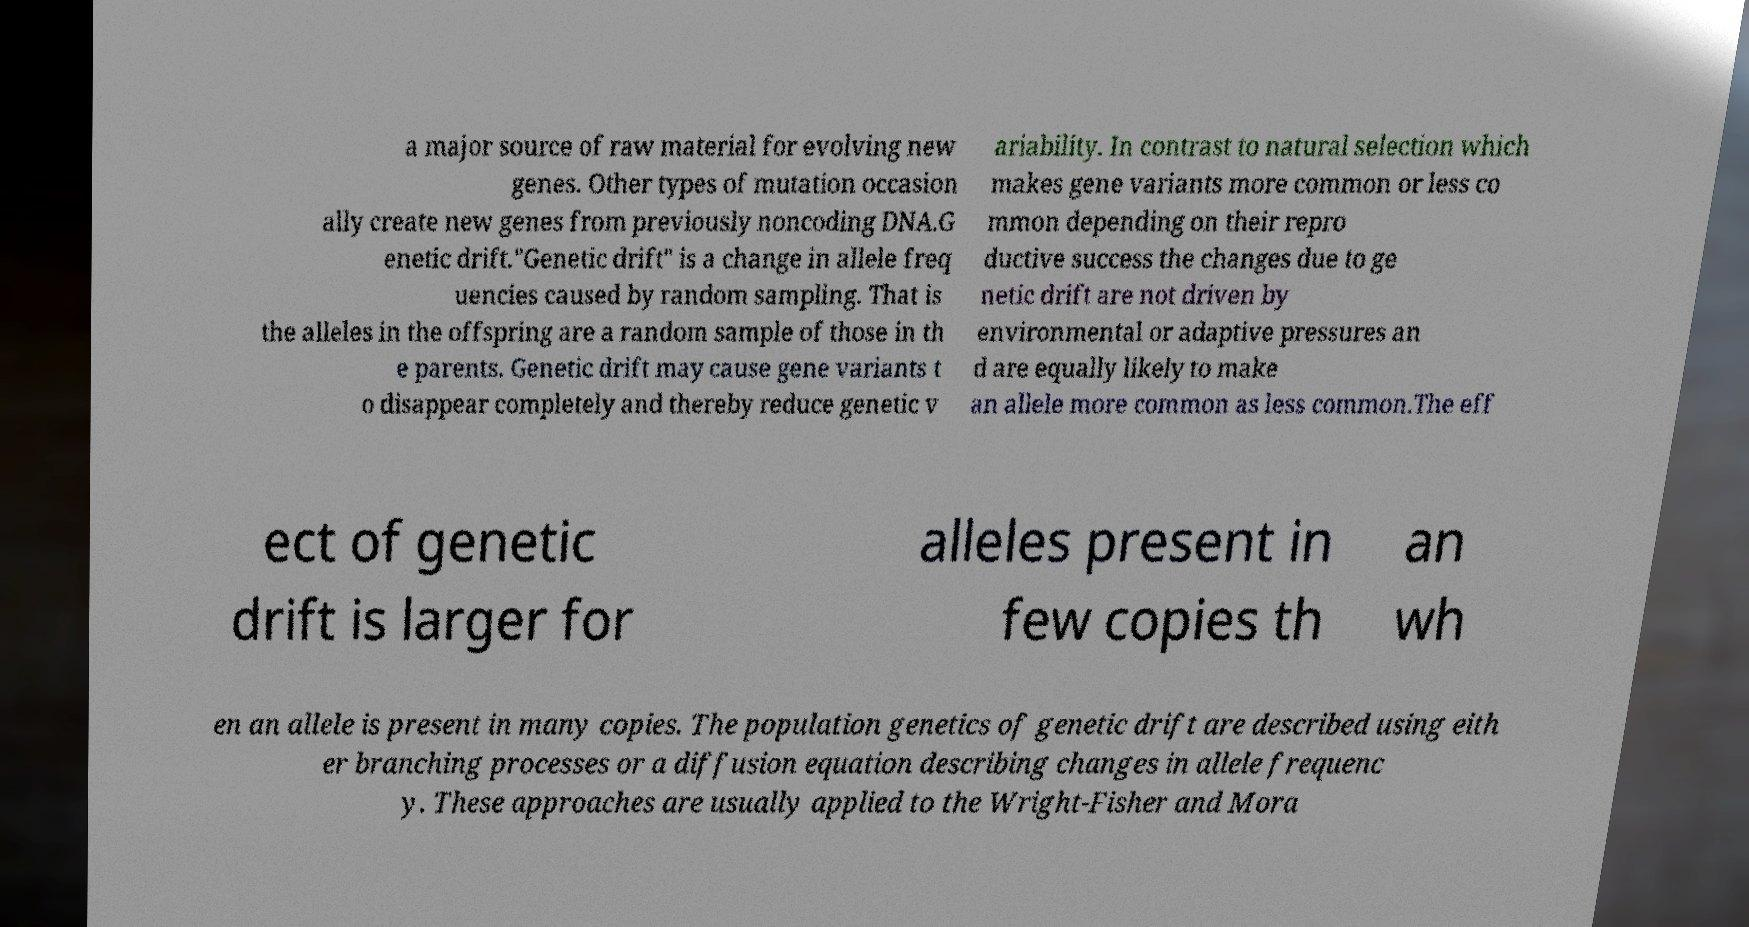Could you assist in decoding the text presented in this image and type it out clearly? a major source of raw material for evolving new genes. Other types of mutation occasion ally create new genes from previously noncoding DNA.G enetic drift."Genetic drift" is a change in allele freq uencies caused by random sampling. That is the alleles in the offspring are a random sample of those in th e parents. Genetic drift may cause gene variants t o disappear completely and thereby reduce genetic v ariability. In contrast to natural selection which makes gene variants more common or less co mmon depending on their repro ductive success the changes due to ge netic drift are not driven by environmental or adaptive pressures an d are equally likely to make an allele more common as less common.The eff ect of genetic drift is larger for alleles present in few copies th an wh en an allele is present in many copies. The population genetics of genetic drift are described using eith er branching processes or a diffusion equation describing changes in allele frequenc y. These approaches are usually applied to the Wright-Fisher and Mora 